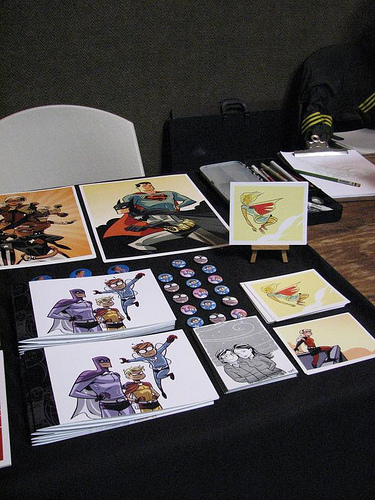<image>
Can you confirm if the picture card is in front of the chair? Yes. The picture card is positioned in front of the chair, appearing closer to the camera viewpoint. 